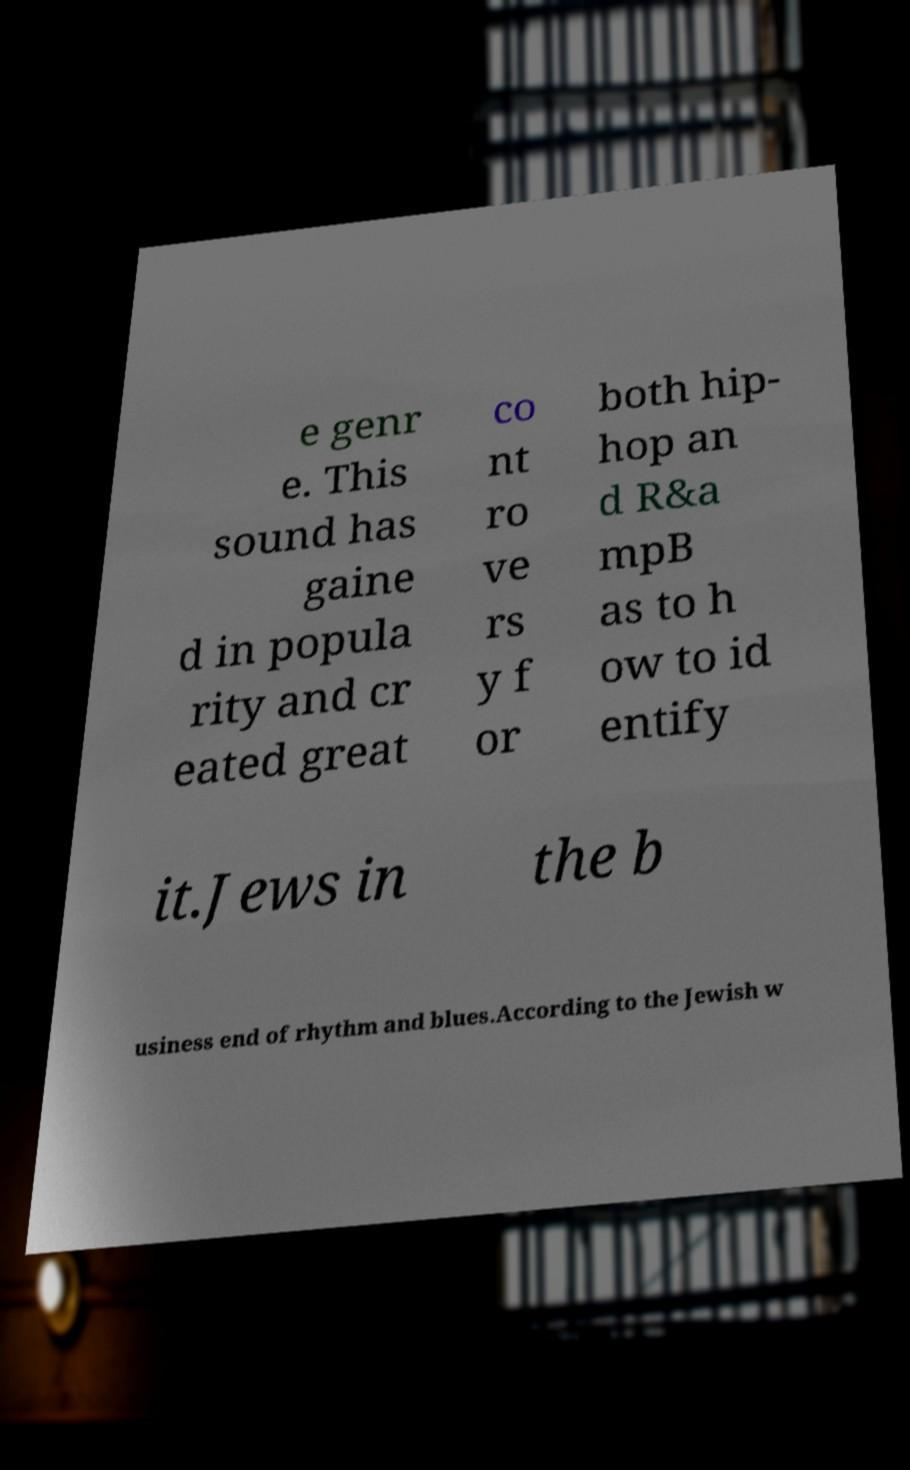There's text embedded in this image that I need extracted. Can you transcribe it verbatim? e genr e. This sound has gaine d in popula rity and cr eated great co nt ro ve rs y f or both hip- hop an d R&a mpB as to h ow to id entify it.Jews in the b usiness end of rhythm and blues.According to the Jewish w 